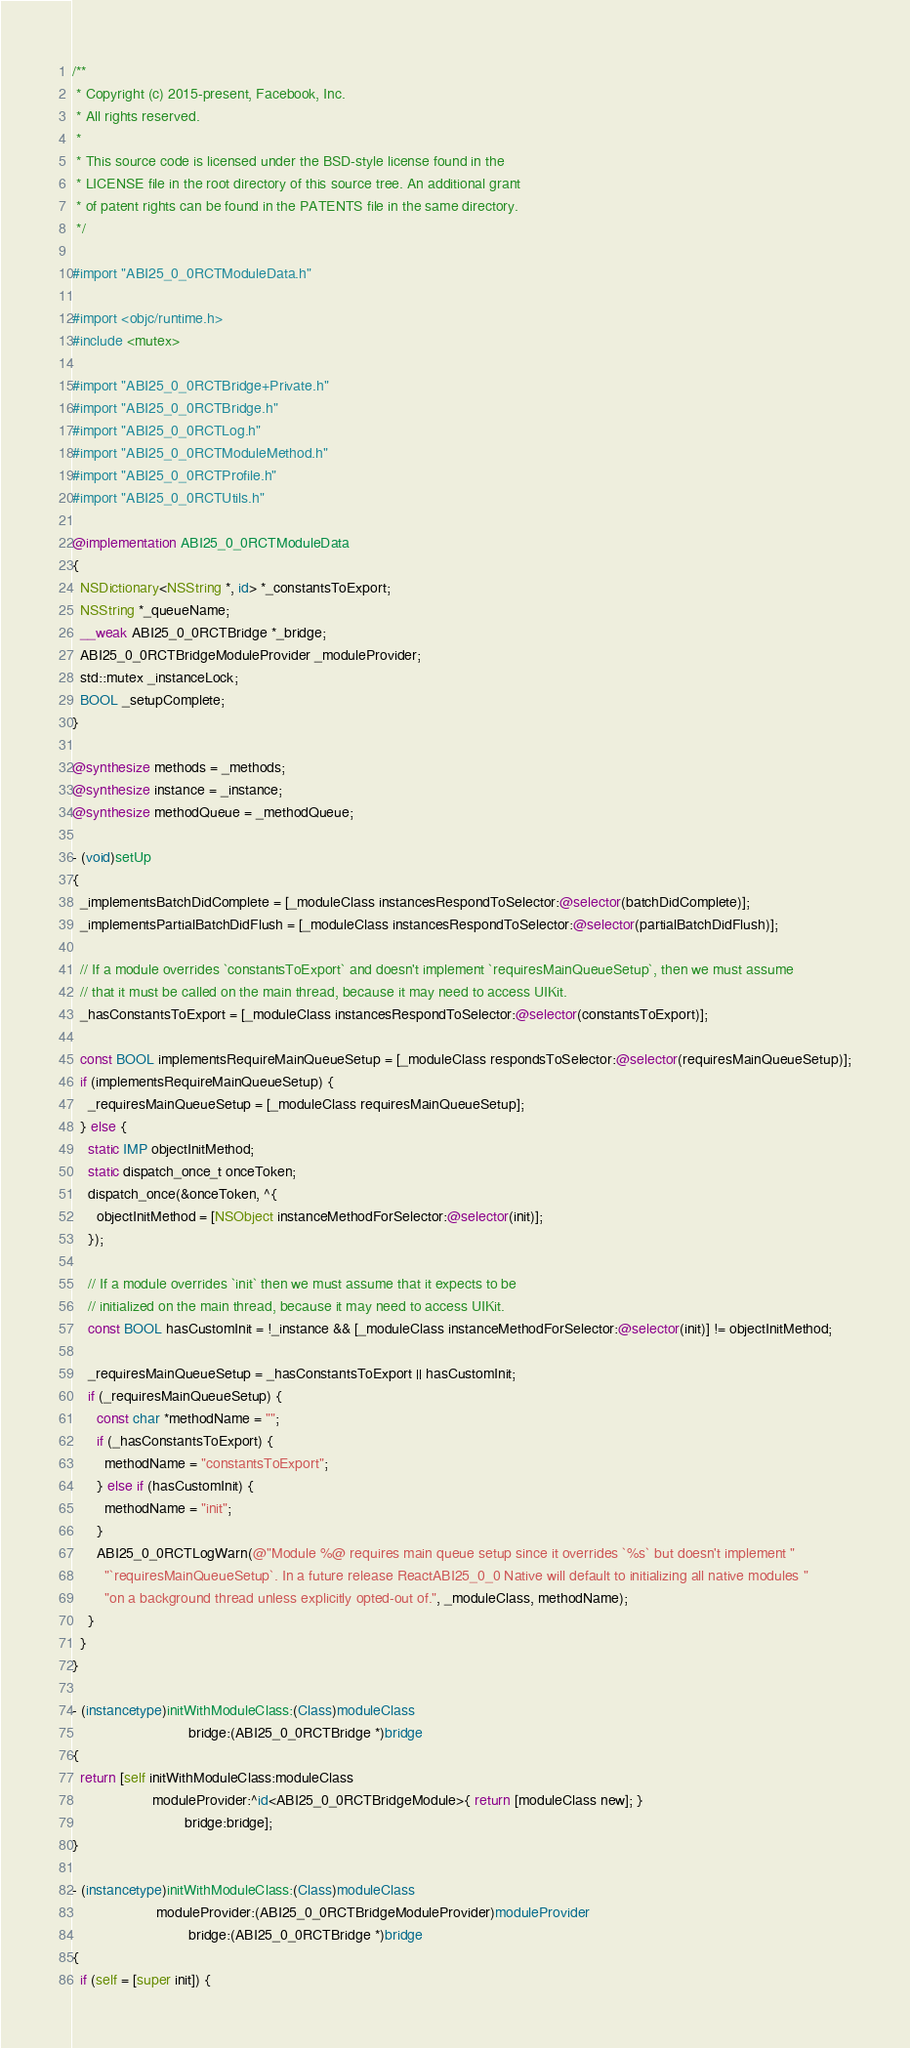Convert code to text. <code><loc_0><loc_0><loc_500><loc_500><_ObjectiveC_>/**
 * Copyright (c) 2015-present, Facebook, Inc.
 * All rights reserved.
 *
 * This source code is licensed under the BSD-style license found in the
 * LICENSE file in the root directory of this source tree. An additional grant
 * of patent rights can be found in the PATENTS file in the same directory.
 */

#import "ABI25_0_0RCTModuleData.h"

#import <objc/runtime.h>
#include <mutex>

#import "ABI25_0_0RCTBridge+Private.h"
#import "ABI25_0_0RCTBridge.h"
#import "ABI25_0_0RCTLog.h"
#import "ABI25_0_0RCTModuleMethod.h"
#import "ABI25_0_0RCTProfile.h"
#import "ABI25_0_0RCTUtils.h"

@implementation ABI25_0_0RCTModuleData
{
  NSDictionary<NSString *, id> *_constantsToExport;
  NSString *_queueName;
  __weak ABI25_0_0RCTBridge *_bridge;
  ABI25_0_0RCTBridgeModuleProvider _moduleProvider;
  std::mutex _instanceLock;
  BOOL _setupComplete;
}

@synthesize methods = _methods;
@synthesize instance = _instance;
@synthesize methodQueue = _methodQueue;

- (void)setUp
{
  _implementsBatchDidComplete = [_moduleClass instancesRespondToSelector:@selector(batchDidComplete)];
  _implementsPartialBatchDidFlush = [_moduleClass instancesRespondToSelector:@selector(partialBatchDidFlush)];

  // If a module overrides `constantsToExport` and doesn't implement `requiresMainQueueSetup`, then we must assume
  // that it must be called on the main thread, because it may need to access UIKit.
  _hasConstantsToExport = [_moduleClass instancesRespondToSelector:@selector(constantsToExport)];

  const BOOL implementsRequireMainQueueSetup = [_moduleClass respondsToSelector:@selector(requiresMainQueueSetup)];
  if (implementsRequireMainQueueSetup) {
    _requiresMainQueueSetup = [_moduleClass requiresMainQueueSetup];
  } else {
    static IMP objectInitMethod;
    static dispatch_once_t onceToken;
    dispatch_once(&onceToken, ^{
      objectInitMethod = [NSObject instanceMethodForSelector:@selector(init)];
    });

    // If a module overrides `init` then we must assume that it expects to be
    // initialized on the main thread, because it may need to access UIKit.
    const BOOL hasCustomInit = !_instance && [_moduleClass instanceMethodForSelector:@selector(init)] != objectInitMethod;

    _requiresMainQueueSetup = _hasConstantsToExport || hasCustomInit;
    if (_requiresMainQueueSetup) {
      const char *methodName = "";
      if (_hasConstantsToExport) {
        methodName = "constantsToExport";
      } else if (hasCustomInit) {
        methodName = "init";
      }
      ABI25_0_0RCTLogWarn(@"Module %@ requires main queue setup since it overrides `%s` but doesn't implement "
        "`requiresMainQueueSetup`. In a future release ReactABI25_0_0 Native will default to initializing all native modules "
        "on a background thread unless explicitly opted-out of.", _moduleClass, methodName);
    }
  }
}

- (instancetype)initWithModuleClass:(Class)moduleClass
                             bridge:(ABI25_0_0RCTBridge *)bridge
{
  return [self initWithModuleClass:moduleClass
                    moduleProvider:^id<ABI25_0_0RCTBridgeModule>{ return [moduleClass new]; }
                            bridge:bridge];
}

- (instancetype)initWithModuleClass:(Class)moduleClass
                     moduleProvider:(ABI25_0_0RCTBridgeModuleProvider)moduleProvider
                             bridge:(ABI25_0_0RCTBridge *)bridge
{
  if (self = [super init]) {</code> 